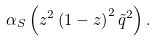Convert formula to latex. <formula><loc_0><loc_0><loc_500><loc_500>\alpha _ { S } \left ( z ^ { 2 } \left ( 1 - z \right ) ^ { 2 } \tilde { q } ^ { 2 } \right ) .</formula> 